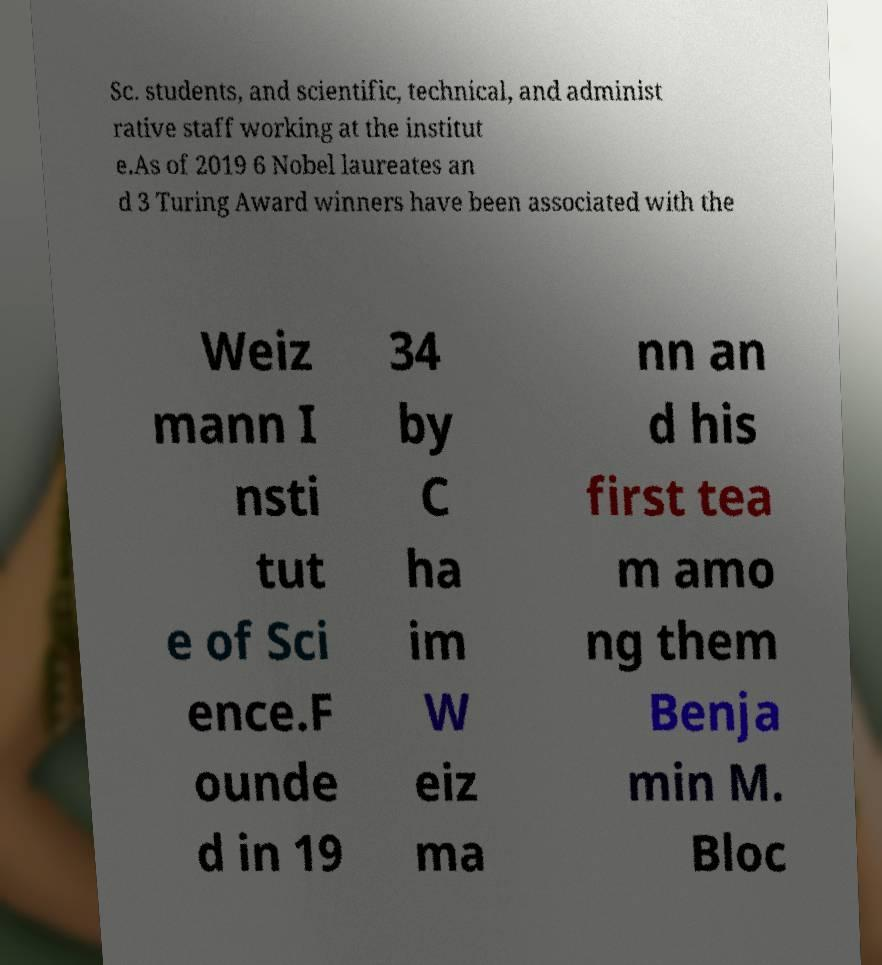Please read and relay the text visible in this image. What does it say? Sc. students, and scientific, technical, and administ rative staff working at the institut e.As of 2019 6 Nobel laureates an d 3 Turing Award winners have been associated with the Weiz mann I nsti tut e of Sci ence.F ounde d in 19 34 by C ha im W eiz ma nn an d his first tea m amo ng them Benja min M. Bloc 